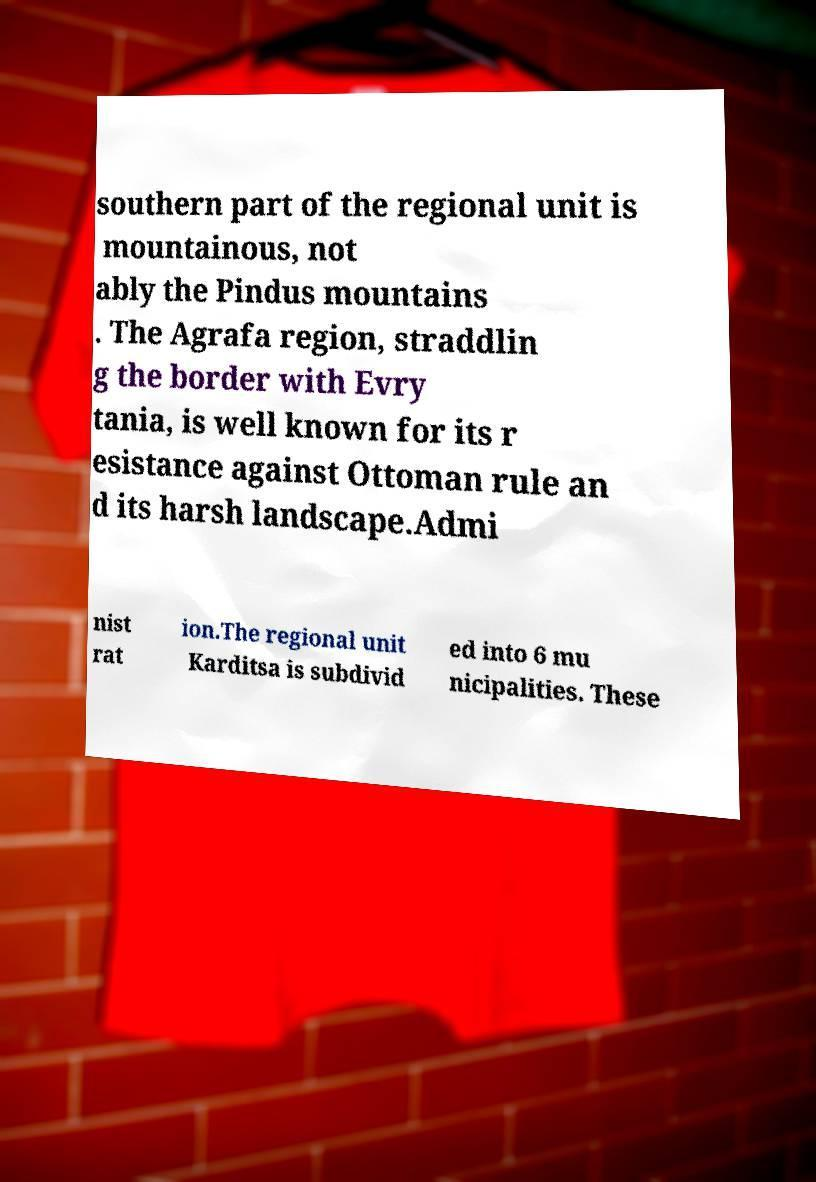Please read and relay the text visible in this image. What does it say? southern part of the regional unit is mountainous, not ably the Pindus mountains . The Agrafa region, straddlin g the border with Evry tania, is well known for its r esistance against Ottoman rule an d its harsh landscape.Admi nist rat ion.The regional unit Karditsa is subdivid ed into 6 mu nicipalities. These 